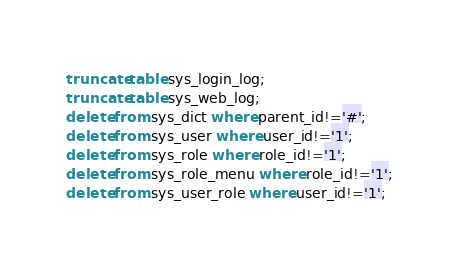<code> <loc_0><loc_0><loc_500><loc_500><_SQL_>truncate table sys_login_log;
truncate table sys_web_log;
delete from sys_dict where parent_id!='#';
delete from sys_user where user_id!='1';
delete from sys_role where role_id!='1';
delete from sys_role_menu where role_id!='1';
delete from sys_user_role where user_id!='1';
</code> 